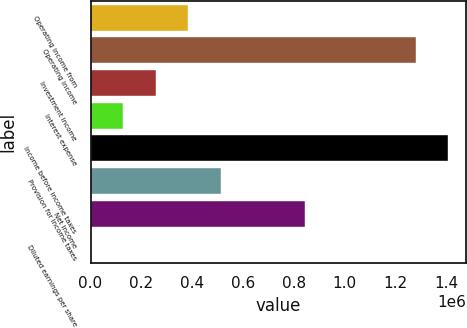Convert chart to OTSL. <chart><loc_0><loc_0><loc_500><loc_500><bar_chart><fcel>Operating income from<fcel>Operating income<fcel>Investment income<fcel>Interest expense<fcel>Income before income taxes<fcel>Provision for income taxes<fcel>Net income<fcel>Diluted earnings per share<nl><fcel>384999<fcel>1.28098e+06<fcel>256667<fcel>128335<fcel>1.40931e+06<fcel>513330<fcel>844611<fcel>3.88<nl></chart> 